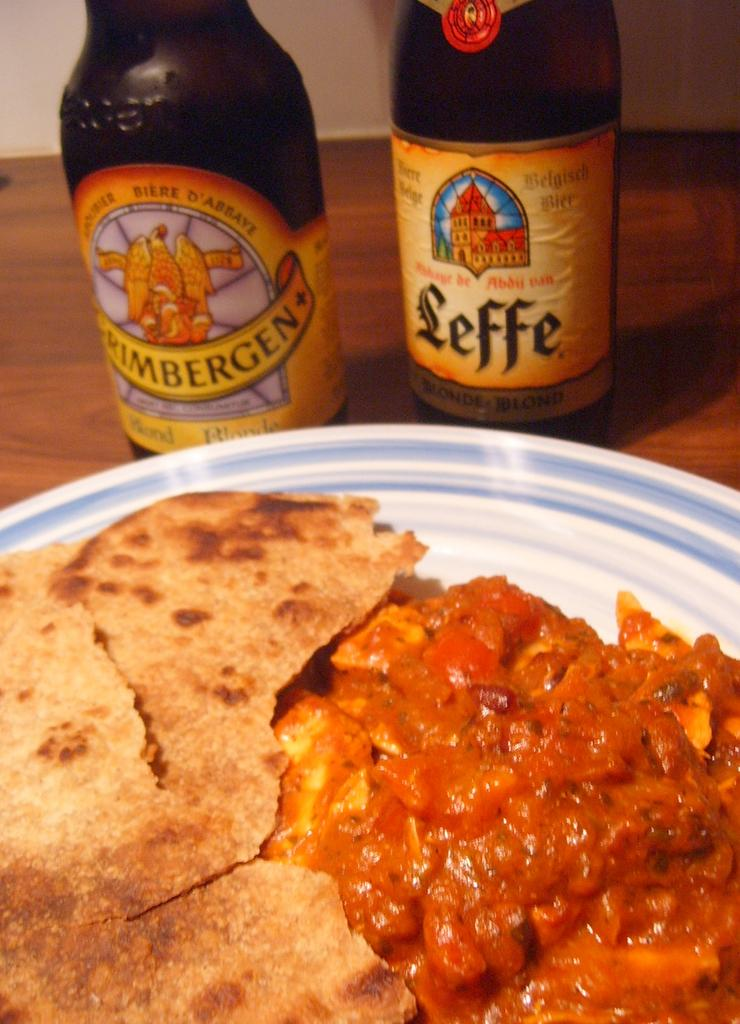<image>
Write a terse but informative summary of the picture. A curry together with two bottles of beer - on with Leffe written on the label. 